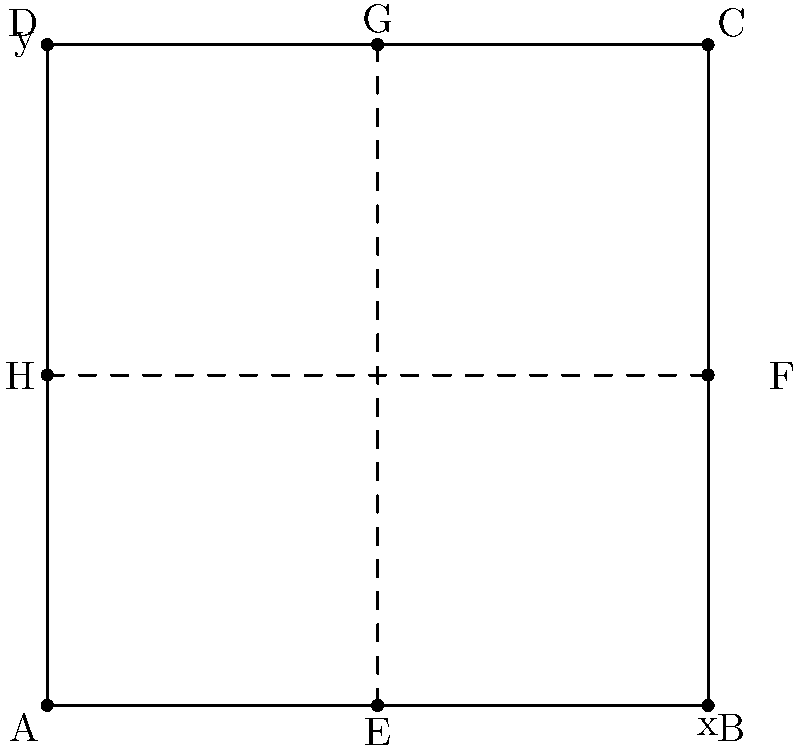A city planner is designing a new intersection for a busy downtown area. The intersection is represented on a coordinate plane where each unit represents 10 meters. Traffic lights need to be installed at the midpoints of each side of the intersection. Given that the intersection is a square with corners at (0,0), (10,0), (10,10), and (0,10), what is the total distance between all four traffic lights, rounded to the nearest meter? Let's approach this step-by-step:

1) First, we need to identify the coordinates of the traffic lights. They are at the midpoints of each side of the square:
   E(5,0), F(10,5), G(5,10), H(0,5)

2) To find the total distance, we need to calculate the distance between:
   E and F, F and G, G and H, H and E

3) We can use the distance formula: $d = \sqrt{(x_2-x_1)^2 + (y_2-y_1)^2}$

4) Calculate EF:
   $EF = \sqrt{(10-5)^2 + (5-0)^2} = \sqrt{25 + 25} = \sqrt{50} = 5\sqrt{2}$

5) Calculate FG:
   $FG = \sqrt{(5-10)^2 + (10-5)^2} = \sqrt{25 + 25} = \sqrt{50} = 5\sqrt{2}$

6) Calculate GH:
   $GH = \sqrt{(0-5)^2 + (5-10)^2} = \sqrt{25 + 25} = \sqrt{50} = 5\sqrt{2}$

7) Calculate HE:
   $HE = \sqrt{(5-0)^2 + (0-5)^2} = \sqrt{25 + 25} = \sqrt{50} = 5\sqrt{2}$

8) Total distance = $EF + FG + GH + HE = 4(5\sqrt{2}) = 20\sqrt{2}$

9) Convert to meters: $20\sqrt{2} * 10 = 200\sqrt{2} \approx 282.84$ meters

10) Rounding to the nearest meter: 283 meters
Answer: 283 meters 